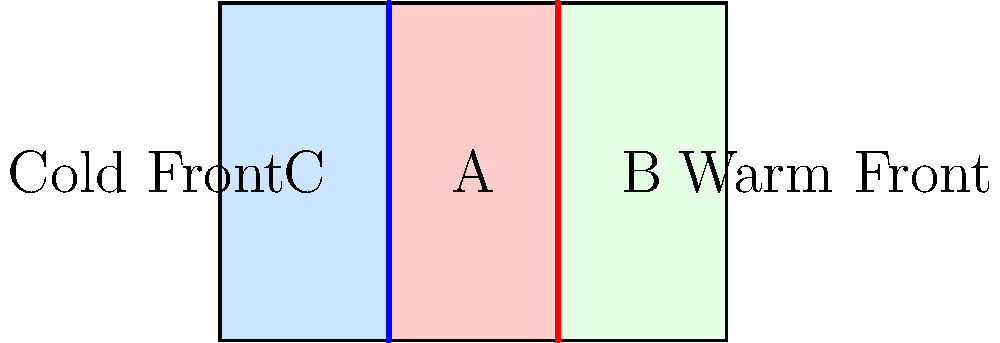A weather map of a region in Canada shows three distinct areas separated by a cold front and a warm front, as illustrated above. The map uses a rectangular projection where 1 unit represents 100 km. If the total area of the map is 24,000 km², calculate the area (in km²) covered by the region marked 'A' between the cold and warm fronts. Let's approach this step-by-step:

1) First, we need to find the dimensions of the entire map:
   Area = length × width
   24,000 = length × width

2) From the diagram, we can see that the width is 2/3 of the length. Let's call the length $l$:
   24,000 = $l$ × $(2/3)l$ = $(2/3)l^2$

3) Solving for $l$:
   $l^2$ = 24,000 × $(3/2)$ = 36,000
   $l$ = √36,000 = 600 km

4) The width is then:
   width = $(2/3)$ × 600 = 400 km

5) Now, we can see that the region 'A' is in the middle third of the map. Its width is:
   $(1/3)$ × 600 = 200 km

6) The height of region 'A' is the same as the map's height, 400 km.

7) Therefore, the area of region 'A' is:
   Area of 'A' = 200 km × 400 km = 80,000 km²
Answer: 80,000 km² 